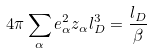Convert formula to latex. <formula><loc_0><loc_0><loc_500><loc_500>4 \pi \sum _ { \alpha } e _ { \alpha } ^ { 2 } z _ { \alpha } l _ { D } ^ { 3 } = \frac { l _ { D } } { \beta }</formula> 